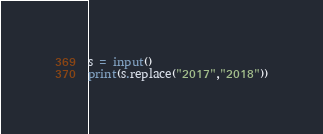<code> <loc_0><loc_0><loc_500><loc_500><_Python_>s = input()
print(s.replace("2017","2018"))
</code> 